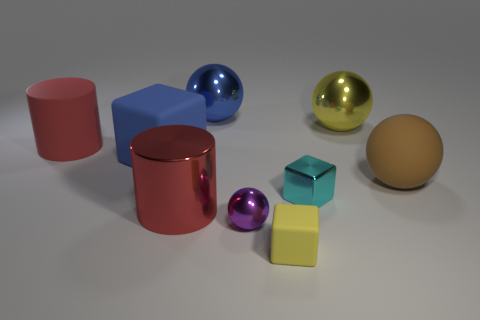There is a yellow thing that is the same material as the big blue sphere; what shape is it? sphere 